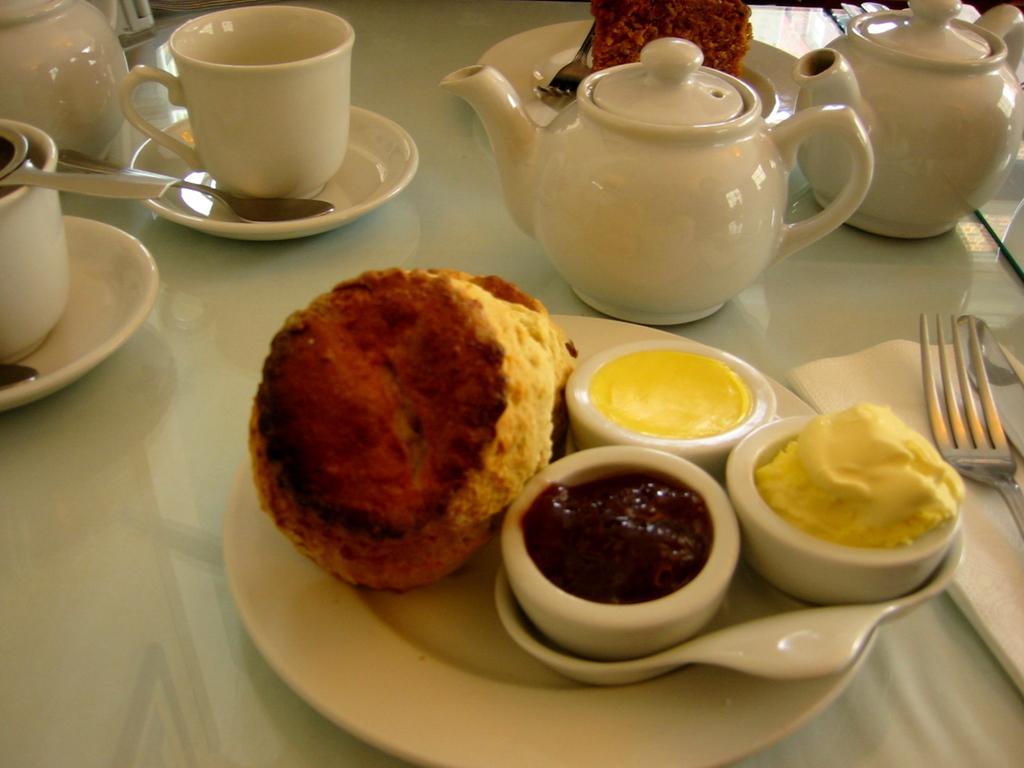Can you describe this image briefly? In the image on the white surface there is a plate. On the plate there is a food item and bowls with food items. On the right side of the image here is a fork and a tissue. And also there are kettles, cups with saucers, and many other things. 